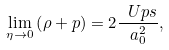Convert formula to latex. <formula><loc_0><loc_0><loc_500><loc_500>\lim _ { \eta \to 0 } \left ( \rho + p \right ) = 2 \frac { \ U p s } { a _ { 0 } ^ { 2 } } ,</formula> 